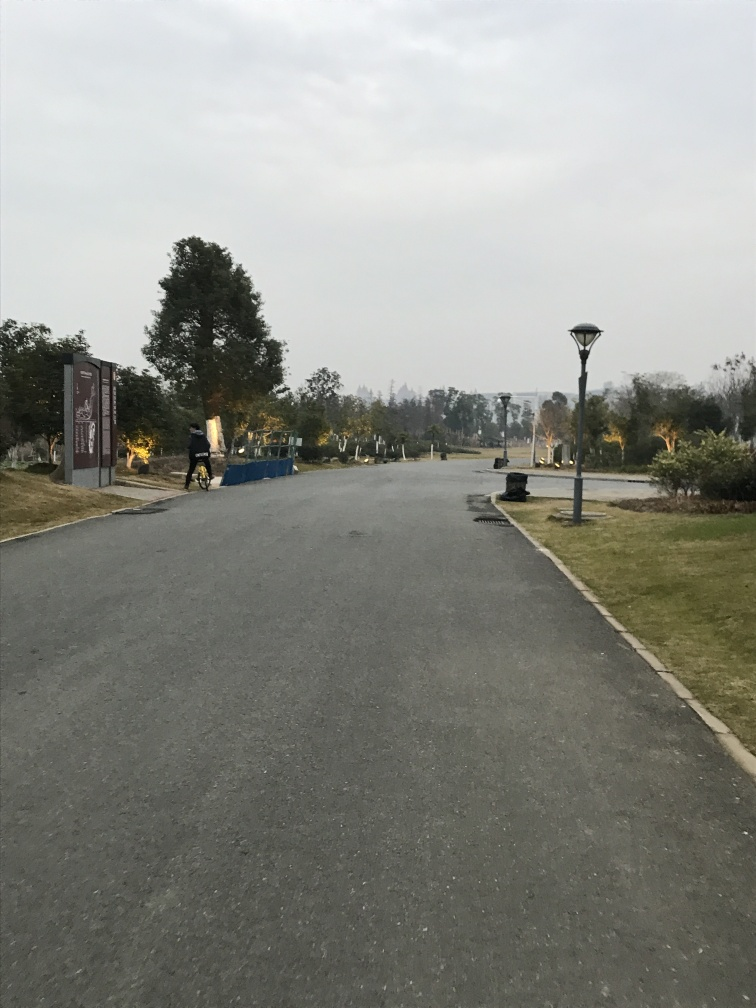What time of day does it appear to be in this image? Based on the lighting and the sky's color, it looks to be either dawn or dusk, with a soft light that suggests the sun is low on the horizon. What season could it be? Considering the trees are still quite full, it might be early autumn or late spring. The still-green grass also supports this timeframe. 